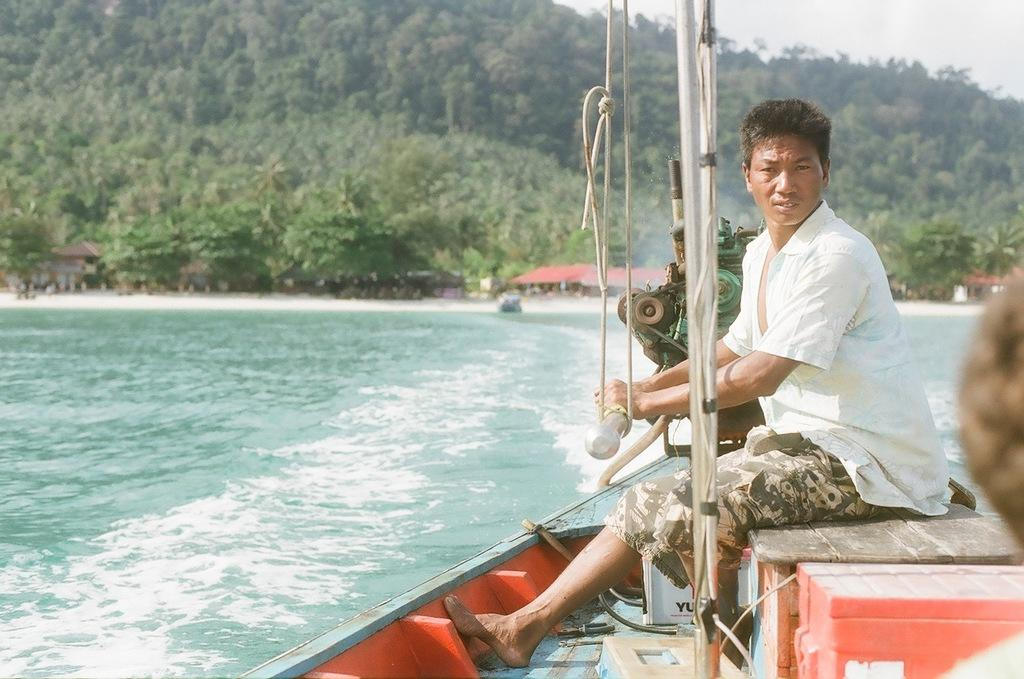What is the person in the image doing? The person is sitting on a board in the image. Where is the person located in the image? The person is on the right side of the image. What can be seen in the background of the image? There are many trees visible in the background of the image. Absurd Question/Answer: How does the person plan to increase their quilt collection while sitting on the board? There is no mention of a quilt collection or any activity related to quilts in the image. The conversation focuses on the person's position and the background, which are the main elements of the image. We start by describing the person's action (sitting on a board) and their location (on the right side of the image). Then, we mention the background, which is filled with trees. We avoid yes/no questions and ensure that the language is simple and clear. Absurd Question/Answer: How many tickets does the person have in their hand while sitting on the board? There is no mention of tickets in the image. 